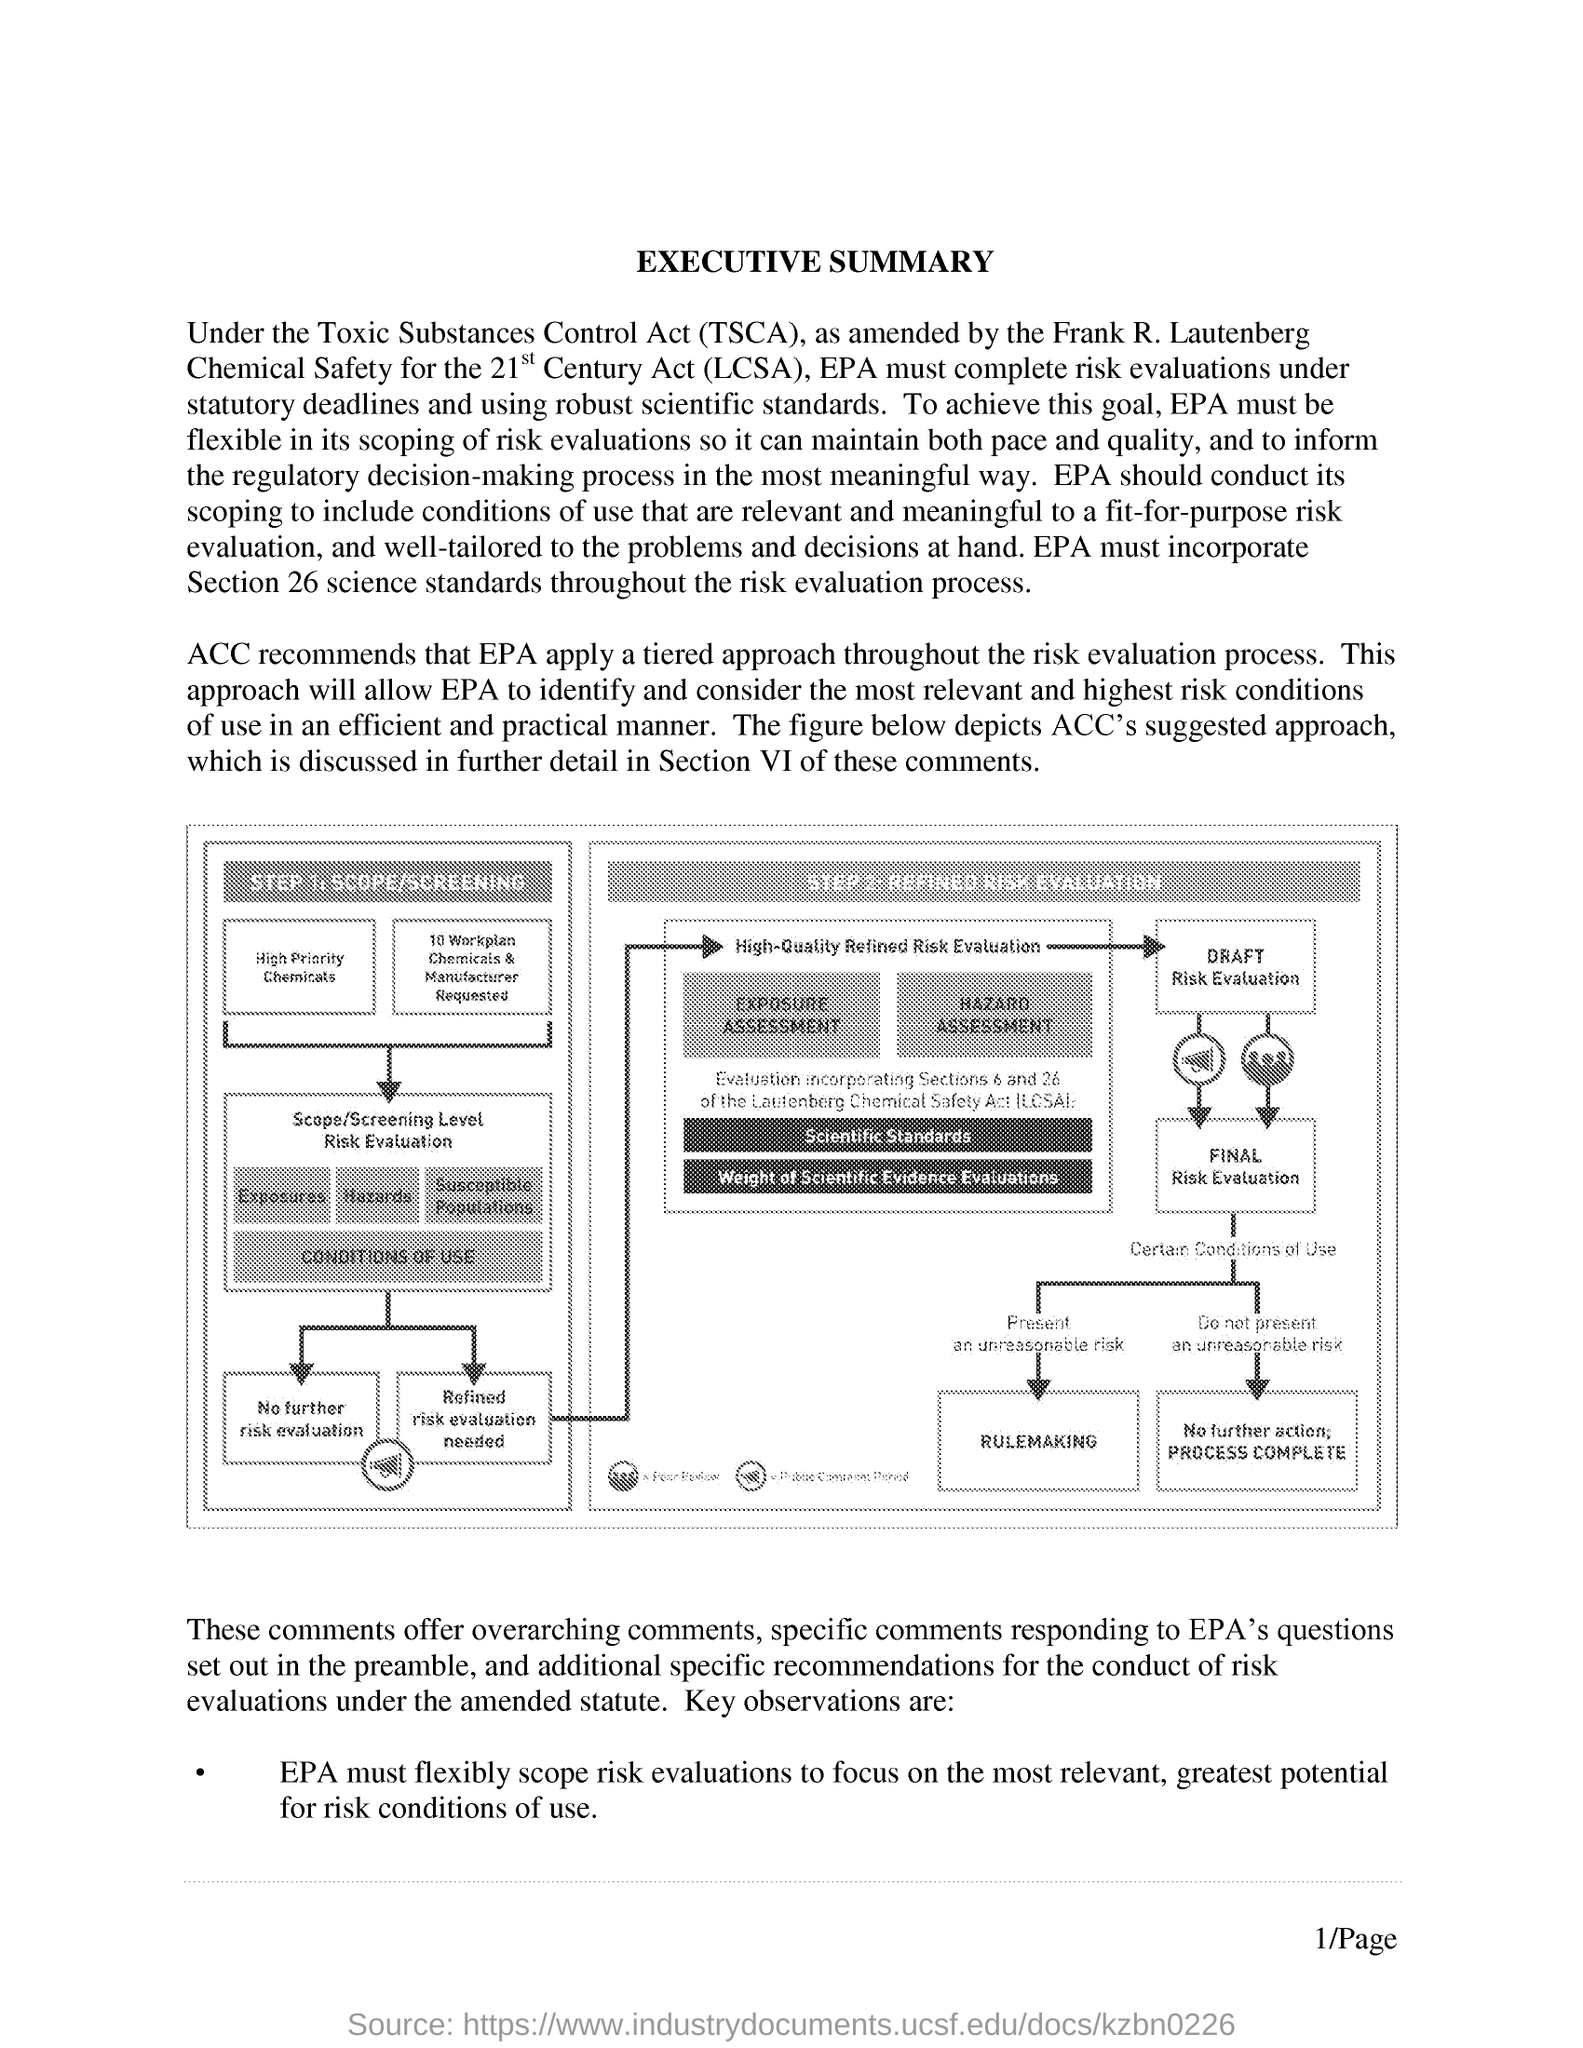Outline some significant characteristics in this image. The first step in the diagram involves SCOPE/SCREENING. The Toxic Substances Control Act (TSCA) is an act that regulates the production, use, and disposal of toxic substances in the United States. 